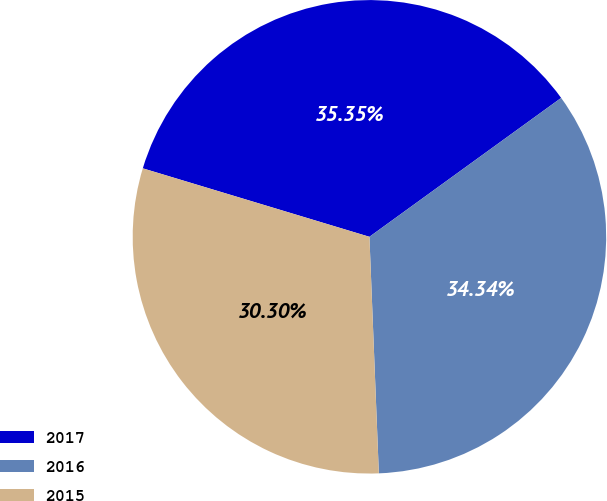Convert chart to OTSL. <chart><loc_0><loc_0><loc_500><loc_500><pie_chart><fcel>2017<fcel>2016<fcel>2015<nl><fcel>35.35%<fcel>34.34%<fcel>30.3%<nl></chart> 